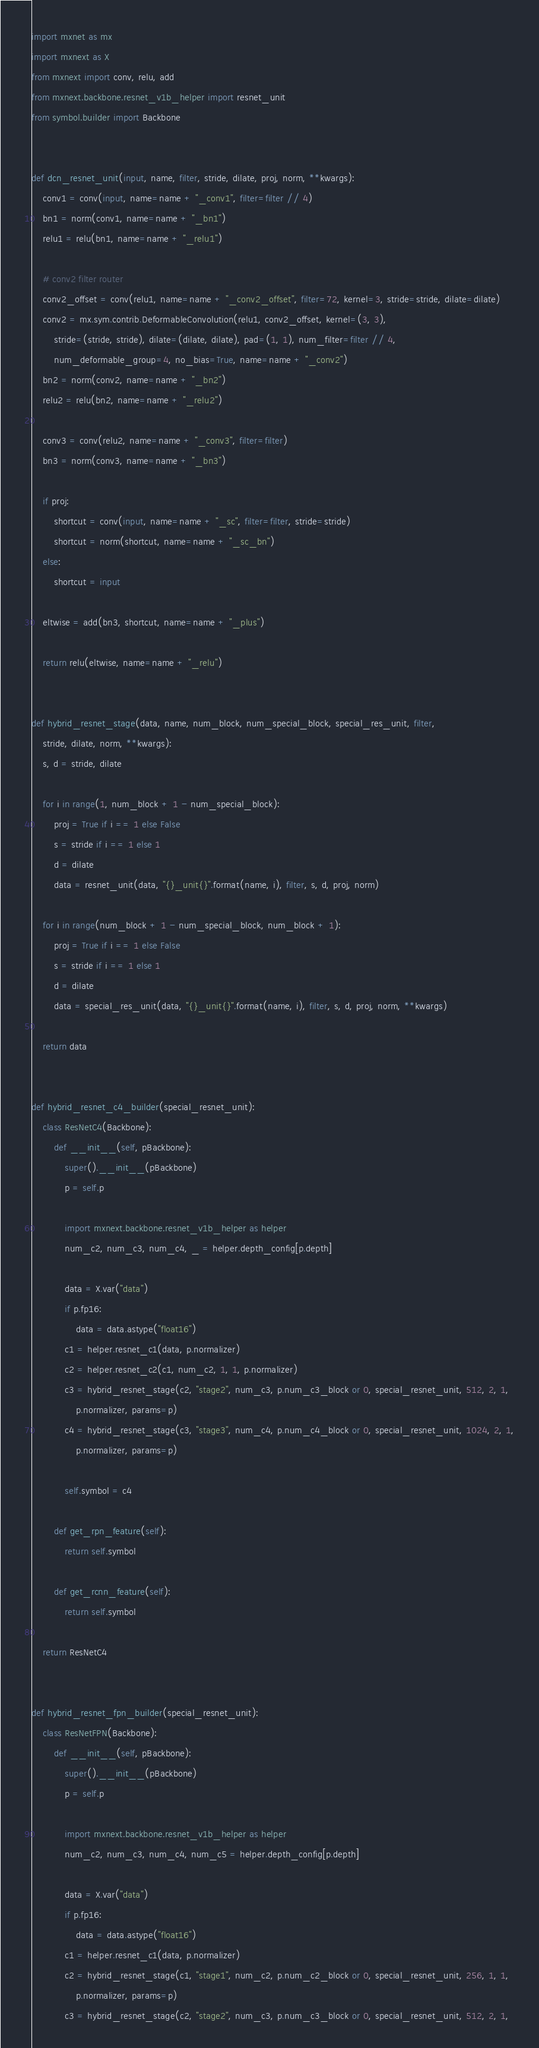Convert code to text. <code><loc_0><loc_0><loc_500><loc_500><_Python_>import mxnet as mx
import mxnext as X
from mxnext import conv, relu, add
from mxnext.backbone.resnet_v1b_helper import resnet_unit
from symbol.builder import Backbone


def dcn_resnet_unit(input, name, filter, stride, dilate, proj, norm, **kwargs):
    conv1 = conv(input, name=name + "_conv1", filter=filter // 4)
    bn1 = norm(conv1, name=name + "_bn1")
    relu1 = relu(bn1, name=name + "_relu1")

    # conv2 filter router
    conv2_offset = conv(relu1, name=name + "_conv2_offset", filter=72, kernel=3, stride=stride, dilate=dilate)
    conv2 = mx.sym.contrib.DeformableConvolution(relu1, conv2_offset, kernel=(3, 3),
        stride=(stride, stride), dilate=(dilate, dilate), pad=(1, 1), num_filter=filter // 4,
        num_deformable_group=4, no_bias=True, name=name + "_conv2")
    bn2 = norm(conv2, name=name + "_bn2")
    relu2 = relu(bn2, name=name + "_relu2")

    conv3 = conv(relu2, name=name + "_conv3", filter=filter)
    bn3 = norm(conv3, name=name + "_bn3")

    if proj:
        shortcut = conv(input, name=name + "_sc", filter=filter, stride=stride)
        shortcut = norm(shortcut, name=name + "_sc_bn")
    else:
        shortcut = input

    eltwise = add(bn3, shortcut, name=name + "_plus")

    return relu(eltwise, name=name + "_relu")


def hybrid_resnet_stage(data, name, num_block, num_special_block, special_res_unit, filter,
    stride, dilate, norm, **kwargs):
    s, d = stride, dilate

    for i in range(1, num_block + 1 - num_special_block):
        proj = True if i == 1 else False
        s = stride if i == 1 else 1
        d = dilate
        data = resnet_unit(data, "{}_unit{}".format(name, i), filter, s, d, proj, norm)

    for i in range(num_block + 1 - num_special_block, num_block + 1):
        proj = True if i == 1 else False
        s = stride if i == 1 else 1
        d = dilate
        data = special_res_unit(data, "{}_unit{}".format(name, i), filter, s, d, proj, norm, **kwargs)

    return data


def hybrid_resnet_c4_builder(special_resnet_unit):
    class ResNetC4(Backbone):
        def __init__(self, pBackbone):
            super().__init__(pBackbone)
            p = self.p

            import mxnext.backbone.resnet_v1b_helper as helper
            num_c2, num_c3, num_c4, _ = helper.depth_config[p.depth]

            data = X.var("data")
            if p.fp16:
                data = data.astype("float16")
            c1 = helper.resnet_c1(data, p.normalizer)
            c2 = helper.resnet_c2(c1, num_c2, 1, 1, p.normalizer)
            c3 = hybrid_resnet_stage(c2, "stage2", num_c3, p.num_c3_block or 0, special_resnet_unit, 512, 2, 1,
                p.normalizer, params=p)
            c4 = hybrid_resnet_stage(c3, "stage3", num_c4, p.num_c4_block or 0, special_resnet_unit, 1024, 2, 1,
                p.normalizer, params=p)

            self.symbol = c4

        def get_rpn_feature(self):
            return self.symbol

        def get_rcnn_feature(self):
            return self.symbol

    return ResNetC4


def hybrid_resnet_fpn_builder(special_resnet_unit):
    class ResNetFPN(Backbone):
        def __init__(self, pBackbone):
            super().__init__(pBackbone)
            p = self.p

            import mxnext.backbone.resnet_v1b_helper as helper
            num_c2, num_c3, num_c4, num_c5 = helper.depth_config[p.depth]

            data = X.var("data")
            if p.fp16:
                data = data.astype("float16")
            c1 = helper.resnet_c1(data, p.normalizer)
            c2 = hybrid_resnet_stage(c1, "stage1", num_c2, p.num_c2_block or 0, special_resnet_unit, 256, 1, 1,
                p.normalizer, params=p)
            c3 = hybrid_resnet_stage(c2, "stage2", num_c3, p.num_c3_block or 0, special_resnet_unit, 512, 2, 1,</code> 